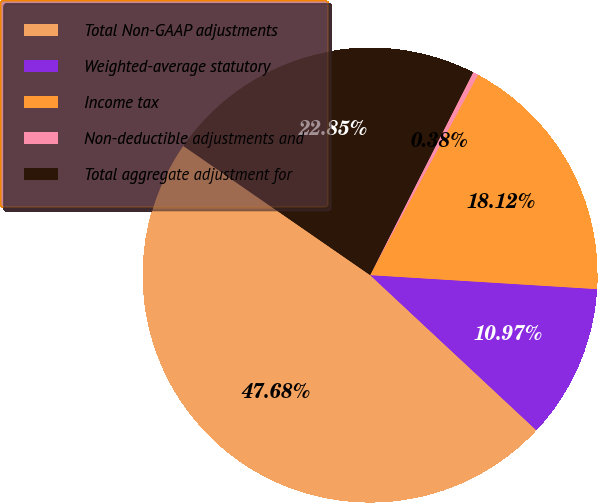Convert chart to OTSL. <chart><loc_0><loc_0><loc_500><loc_500><pie_chart><fcel>Total Non-GAAP adjustments<fcel>Weighted-average statutory<fcel>Income tax<fcel>Non-deductible adjustments and<fcel>Total aggregate adjustment for<nl><fcel>47.68%<fcel>10.97%<fcel>18.12%<fcel>0.38%<fcel>22.85%<nl></chart> 